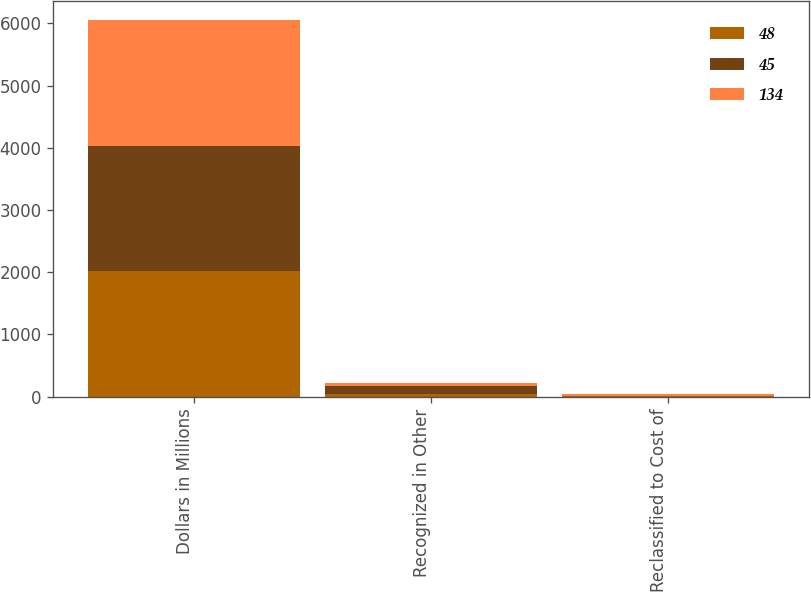Convert chart. <chart><loc_0><loc_0><loc_500><loc_500><stacked_bar_chart><ecel><fcel>Dollars in Millions<fcel>Recognized in Other<fcel>Reclassified to Cost of<nl><fcel>48<fcel>2018<fcel>45<fcel>4<nl><fcel>45<fcel>2017<fcel>134<fcel>12<nl><fcel>134<fcel>2016<fcel>48<fcel>20<nl></chart> 